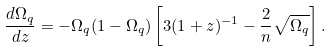<formula> <loc_0><loc_0><loc_500><loc_500>\frac { d \Omega _ { q } } { d z } = - \Omega _ { q } ( 1 - \Omega _ { q } ) \left [ 3 ( 1 + z ) ^ { - 1 } - \frac { 2 } { n } \sqrt { \Omega _ { q } } \right ] .</formula> 